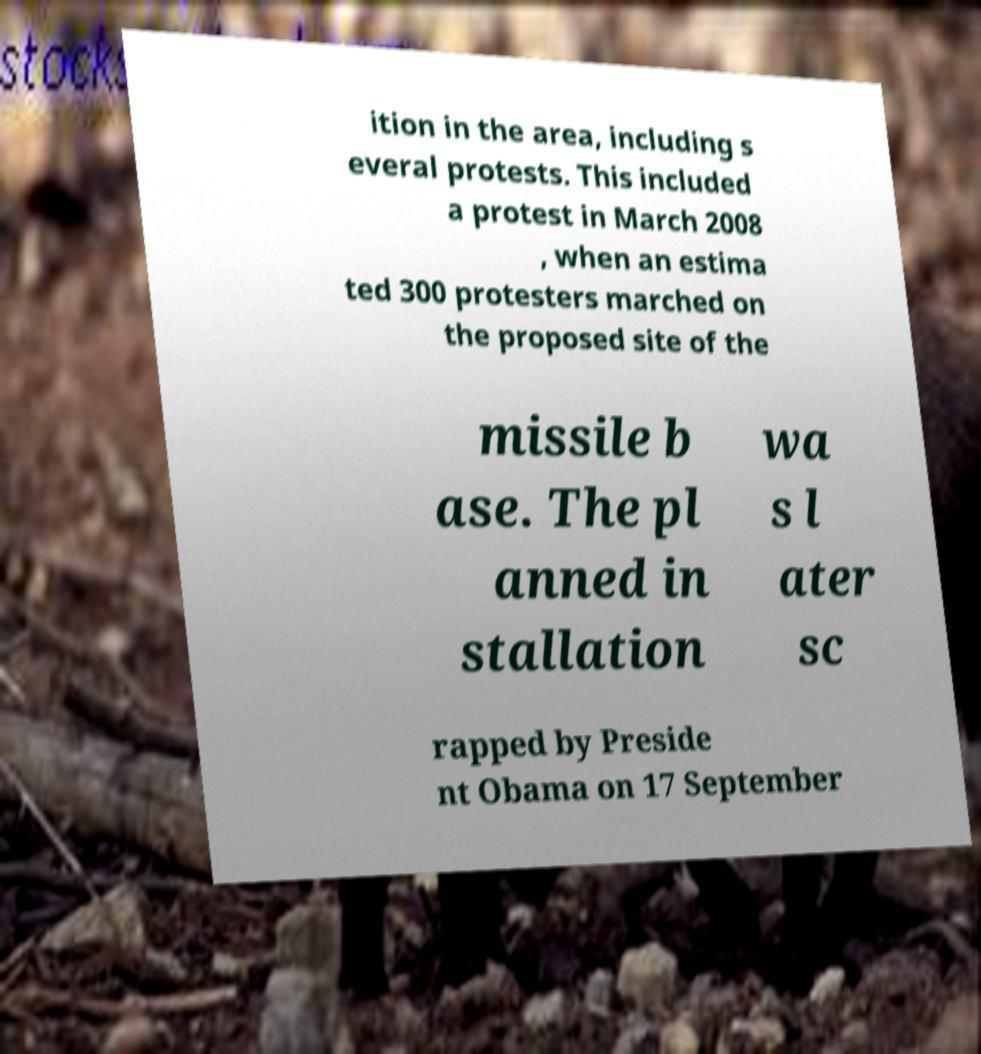Can you read and provide the text displayed in the image?This photo seems to have some interesting text. Can you extract and type it out for me? ition in the area, including s everal protests. This included a protest in March 2008 , when an estima ted 300 protesters marched on the proposed site of the missile b ase. The pl anned in stallation wa s l ater sc rapped by Preside nt Obama on 17 September 